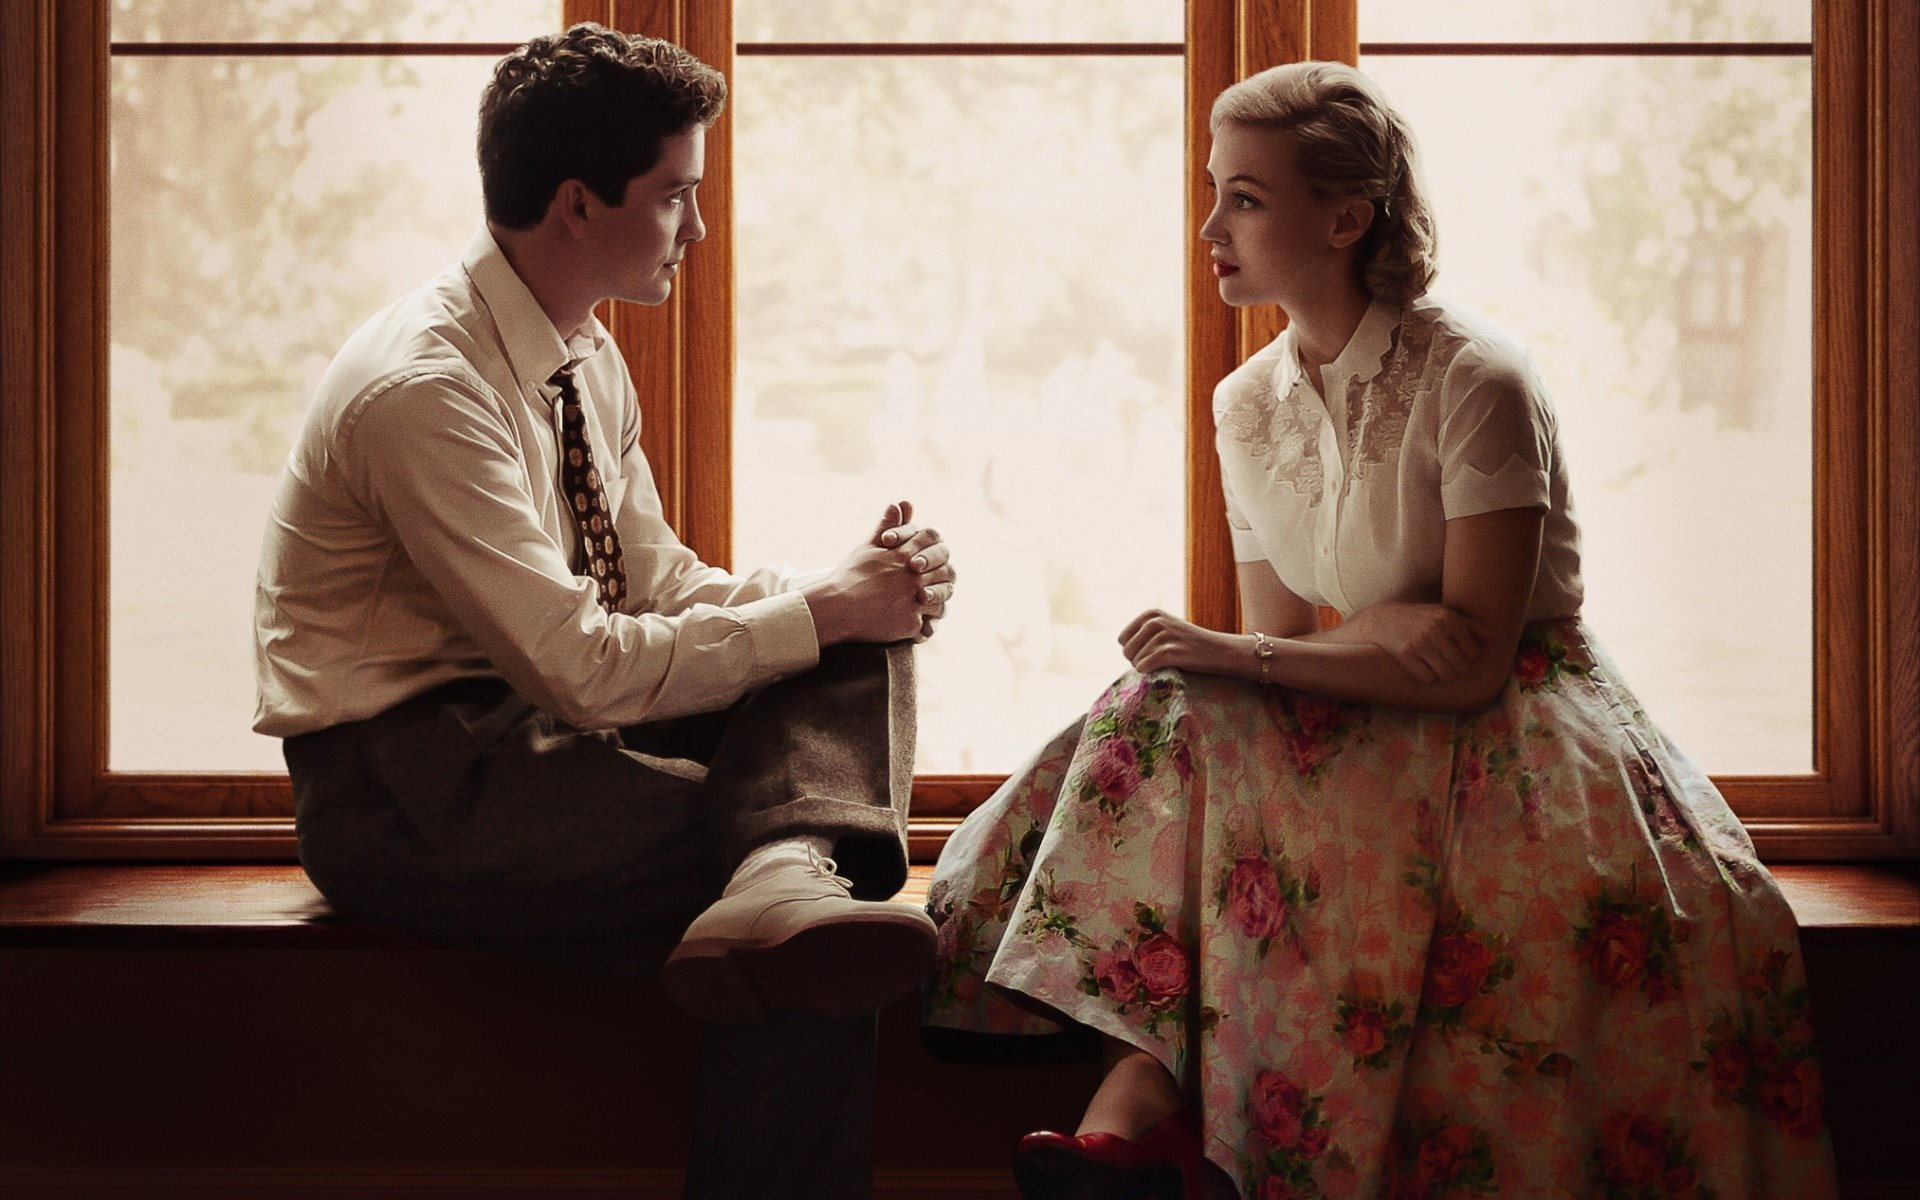Can you describe the main features of this image for me? The image portrays a poignant moment between a woman and a man seated on a window sill, immersed in a deep, possibly reflective dialogue. The woman is elegantly dressed in a vintage white lace blouse and a vibrant, floral skirt in shades of pink and green, with distinctive red heels enhancing her poised appearance. Her hair is styled in soft curls, complementing her gentle, introspective expression. The man, in a refined ensemble of a white shirt, dark vest, and patterned tie with suspenders, mirrors her contemplative mood. Soft, natural light filters through the window, casting gentle shadows and contributing to a serene, almost nostalgic atmosphere. The background, blurred and washed out, hints at a tranquil, leafy exterior, isolating the pair in their shared moment of quiet connection. This setting, along with their attire, suggests a scene from a mid-20th-century period, evoking a sense of timeless elegance and emotional depth. 